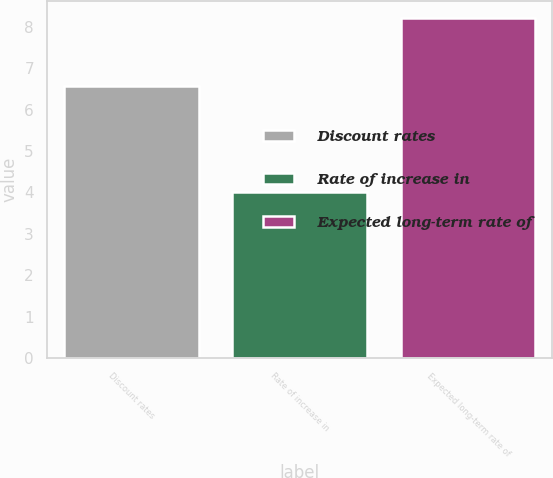<chart> <loc_0><loc_0><loc_500><loc_500><bar_chart><fcel>Discount rates<fcel>Rate of increase in<fcel>Expected long-term rate of<nl><fcel>6.58<fcel>4<fcel>8.21<nl></chart> 